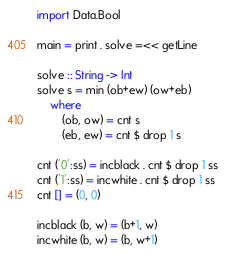<code> <loc_0><loc_0><loc_500><loc_500><_Haskell_>import Data.Bool

main = print . solve =<< getLine

solve :: String -> Int
solve s = min (ob+ew) (ow+eb)
    where
        (ob, ow) = cnt s
        (eb, ew) = cnt $ drop 1 s

cnt ('0':ss) = incblack . cnt $ drop 1 ss
cnt ('1':ss) = incwhite . cnt $ drop 1 ss
cnt [] = (0, 0)

incblack (b, w) = (b+1, w)
incwhite (b, w) = (b, w+1)
</code> 